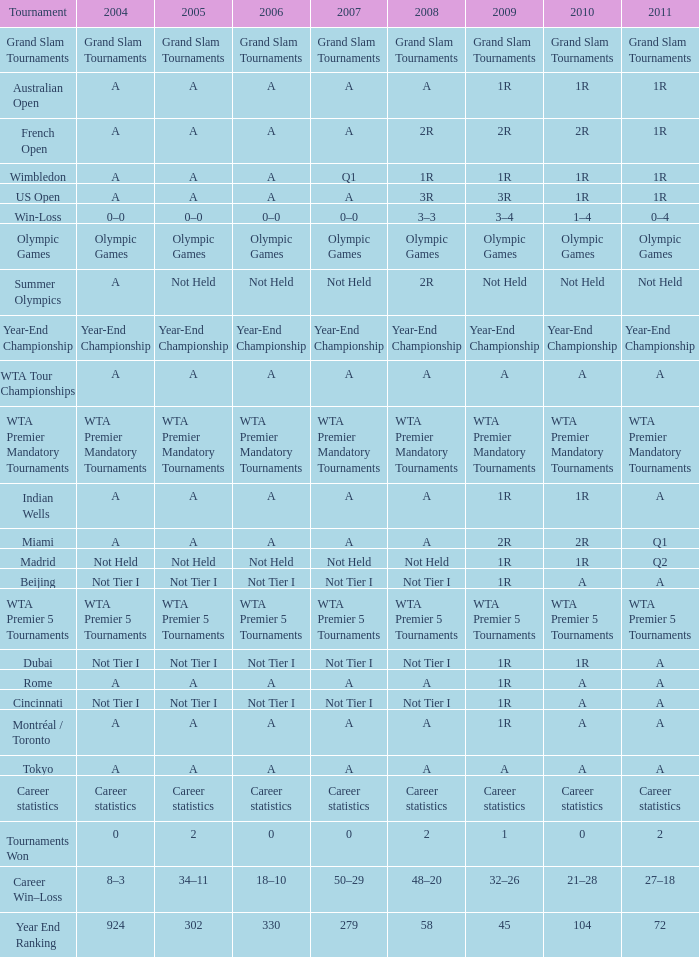What is 2011, when 2010 is "WTA Premier 5 Tournaments"? WTA Premier 5 Tournaments. 